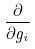Convert formula to latex. <formula><loc_0><loc_0><loc_500><loc_500>\frac { \partial } { \partial g _ { i } }</formula> 